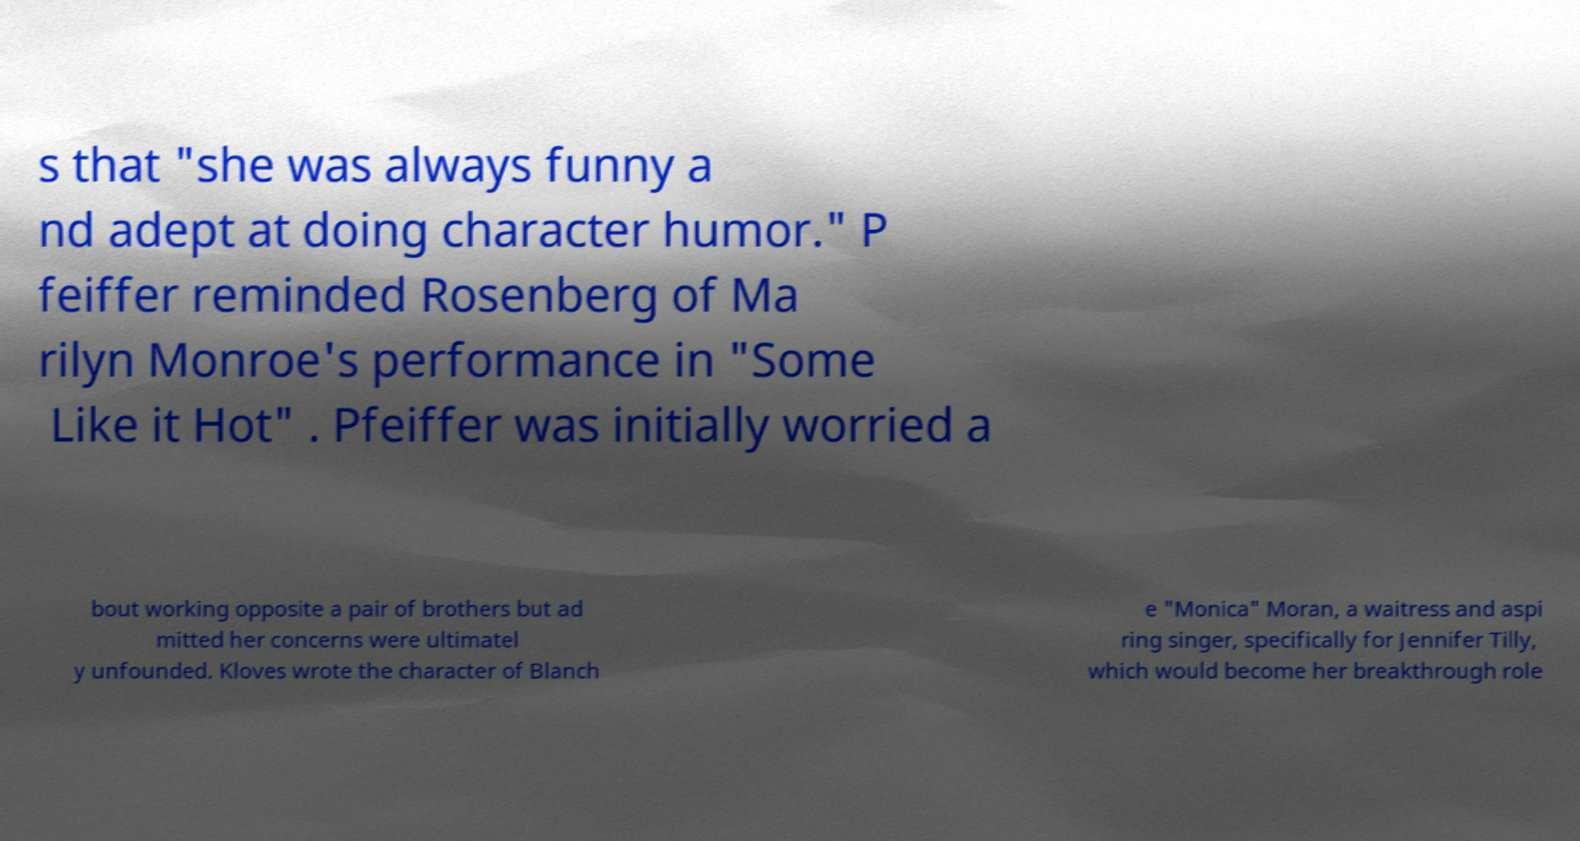I need the written content from this picture converted into text. Can you do that? s that "she was always funny a nd adept at doing character humor." P feiffer reminded Rosenberg of Ma rilyn Monroe's performance in "Some Like it Hot" . Pfeiffer was initially worried a bout working opposite a pair of brothers but ad mitted her concerns were ultimatel y unfounded. Kloves wrote the character of Blanch e "Monica" Moran, a waitress and aspi ring singer, specifically for Jennifer Tilly, which would become her breakthrough role 